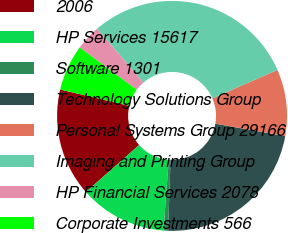Convert chart. <chart><loc_0><loc_0><loc_500><loc_500><pie_chart><fcel>2006<fcel>HP Services 15617<fcel>Software 1301<fcel>Technology Solutions Group<fcel>Personal Systems Group 29166<fcel>Imaging and Printing Group<fcel>HP Financial Services 2078<fcel>Corporate Investments 566<nl><fcel>15.2%<fcel>12.29%<fcel>0.64%<fcel>22.73%<fcel>9.37%<fcel>29.76%<fcel>3.55%<fcel>6.46%<nl></chart> 